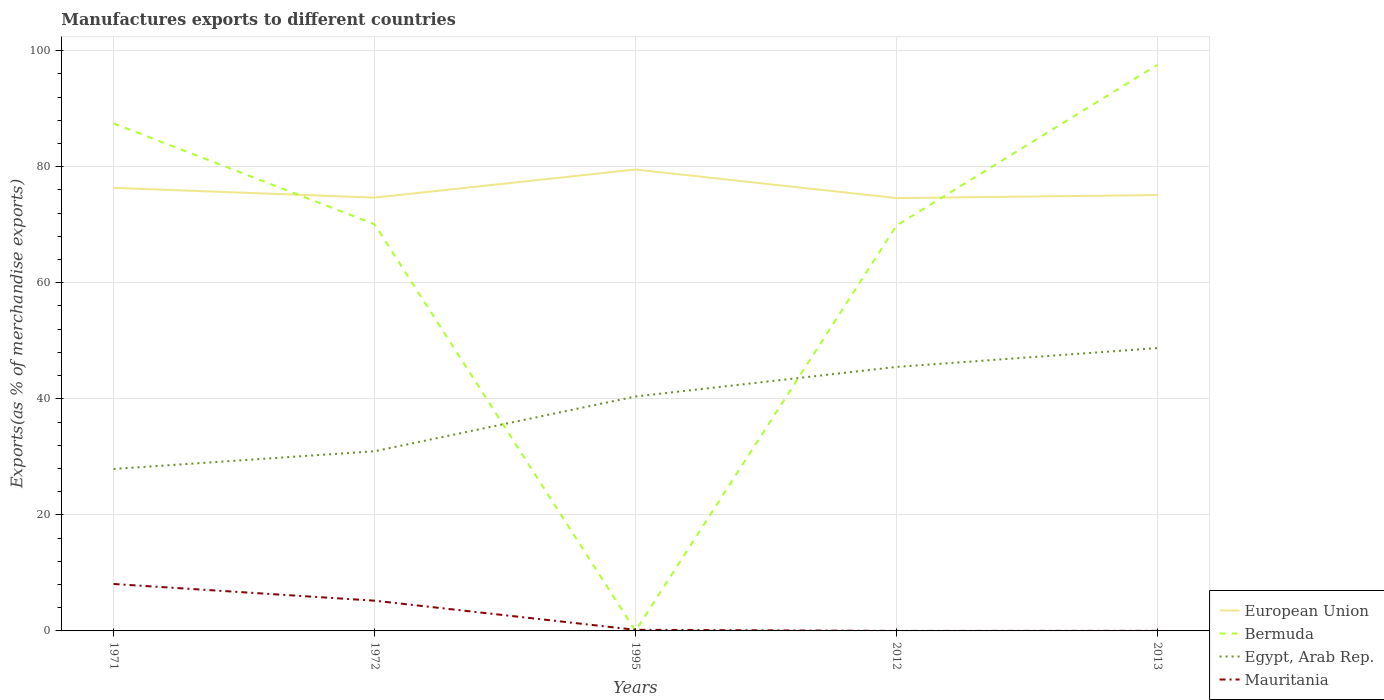How many different coloured lines are there?
Give a very brief answer. 4. Does the line corresponding to Egypt, Arab Rep. intersect with the line corresponding to Bermuda?
Offer a terse response. Yes. Is the number of lines equal to the number of legend labels?
Provide a succinct answer. Yes. Across all years, what is the maximum percentage of exports to different countries in European Union?
Provide a succinct answer. 74.58. In which year was the percentage of exports to different countries in Egypt, Arab Rep. maximum?
Keep it short and to the point. 1971. What is the total percentage of exports to different countries in Egypt, Arab Rep. in the graph?
Provide a short and direct response. -17.58. What is the difference between the highest and the second highest percentage of exports to different countries in Egypt, Arab Rep.?
Your answer should be very brief. 20.83. How many years are there in the graph?
Your response must be concise. 5. What is the difference between two consecutive major ticks on the Y-axis?
Provide a succinct answer. 20. How many legend labels are there?
Your response must be concise. 4. What is the title of the graph?
Give a very brief answer. Manufactures exports to different countries. Does "New Caledonia" appear as one of the legend labels in the graph?
Provide a succinct answer. No. What is the label or title of the X-axis?
Offer a very short reply. Years. What is the label or title of the Y-axis?
Offer a terse response. Exports(as % of merchandise exports). What is the Exports(as % of merchandise exports) of European Union in 1971?
Keep it short and to the point. 76.35. What is the Exports(as % of merchandise exports) of Bermuda in 1971?
Your response must be concise. 87.46. What is the Exports(as % of merchandise exports) in Egypt, Arab Rep. in 1971?
Keep it short and to the point. 27.91. What is the Exports(as % of merchandise exports) in Mauritania in 1971?
Give a very brief answer. 8.09. What is the Exports(as % of merchandise exports) in European Union in 1972?
Your answer should be very brief. 74.67. What is the Exports(as % of merchandise exports) of Bermuda in 1972?
Provide a short and direct response. 70.08. What is the Exports(as % of merchandise exports) in Egypt, Arab Rep. in 1972?
Offer a very short reply. 30.96. What is the Exports(as % of merchandise exports) in Mauritania in 1972?
Offer a very short reply. 5.21. What is the Exports(as % of merchandise exports) in European Union in 1995?
Make the answer very short. 79.51. What is the Exports(as % of merchandise exports) of Bermuda in 1995?
Your answer should be compact. 0.01. What is the Exports(as % of merchandise exports) of Egypt, Arab Rep. in 1995?
Keep it short and to the point. 40.4. What is the Exports(as % of merchandise exports) in Mauritania in 1995?
Provide a short and direct response. 0.19. What is the Exports(as % of merchandise exports) in European Union in 2012?
Give a very brief answer. 74.58. What is the Exports(as % of merchandise exports) in Bermuda in 2012?
Ensure brevity in your answer.  69.85. What is the Exports(as % of merchandise exports) in Egypt, Arab Rep. in 2012?
Your answer should be compact. 45.49. What is the Exports(as % of merchandise exports) of Mauritania in 2012?
Your answer should be compact. 0. What is the Exports(as % of merchandise exports) in European Union in 2013?
Provide a short and direct response. 75.11. What is the Exports(as % of merchandise exports) of Bermuda in 2013?
Your answer should be compact. 97.54. What is the Exports(as % of merchandise exports) of Egypt, Arab Rep. in 2013?
Your answer should be compact. 48.74. What is the Exports(as % of merchandise exports) in Mauritania in 2013?
Your answer should be compact. 0.02. Across all years, what is the maximum Exports(as % of merchandise exports) in European Union?
Offer a terse response. 79.51. Across all years, what is the maximum Exports(as % of merchandise exports) in Bermuda?
Offer a terse response. 97.54. Across all years, what is the maximum Exports(as % of merchandise exports) of Egypt, Arab Rep.?
Give a very brief answer. 48.74. Across all years, what is the maximum Exports(as % of merchandise exports) in Mauritania?
Make the answer very short. 8.09. Across all years, what is the minimum Exports(as % of merchandise exports) in European Union?
Make the answer very short. 74.58. Across all years, what is the minimum Exports(as % of merchandise exports) in Bermuda?
Keep it short and to the point. 0.01. Across all years, what is the minimum Exports(as % of merchandise exports) in Egypt, Arab Rep.?
Give a very brief answer. 27.91. Across all years, what is the minimum Exports(as % of merchandise exports) in Mauritania?
Your response must be concise. 0. What is the total Exports(as % of merchandise exports) of European Union in the graph?
Ensure brevity in your answer.  380.22. What is the total Exports(as % of merchandise exports) of Bermuda in the graph?
Keep it short and to the point. 324.94. What is the total Exports(as % of merchandise exports) of Egypt, Arab Rep. in the graph?
Offer a very short reply. 193.5. What is the total Exports(as % of merchandise exports) in Mauritania in the graph?
Provide a succinct answer. 13.51. What is the difference between the Exports(as % of merchandise exports) in European Union in 1971 and that in 1972?
Keep it short and to the point. 1.68. What is the difference between the Exports(as % of merchandise exports) in Bermuda in 1971 and that in 1972?
Provide a succinct answer. 17.37. What is the difference between the Exports(as % of merchandise exports) in Egypt, Arab Rep. in 1971 and that in 1972?
Provide a succinct answer. -3.05. What is the difference between the Exports(as % of merchandise exports) of Mauritania in 1971 and that in 1972?
Your answer should be very brief. 2.88. What is the difference between the Exports(as % of merchandise exports) of European Union in 1971 and that in 1995?
Ensure brevity in your answer.  -3.16. What is the difference between the Exports(as % of merchandise exports) in Bermuda in 1971 and that in 1995?
Your answer should be very brief. 87.45. What is the difference between the Exports(as % of merchandise exports) of Egypt, Arab Rep. in 1971 and that in 1995?
Ensure brevity in your answer.  -12.49. What is the difference between the Exports(as % of merchandise exports) in Mauritania in 1971 and that in 1995?
Make the answer very short. 7.9. What is the difference between the Exports(as % of merchandise exports) in European Union in 1971 and that in 2012?
Offer a very short reply. 1.76. What is the difference between the Exports(as % of merchandise exports) of Bermuda in 1971 and that in 2012?
Offer a terse response. 17.61. What is the difference between the Exports(as % of merchandise exports) in Egypt, Arab Rep. in 1971 and that in 2012?
Your answer should be very brief. -17.58. What is the difference between the Exports(as % of merchandise exports) in Mauritania in 1971 and that in 2012?
Offer a very short reply. 8.09. What is the difference between the Exports(as % of merchandise exports) in European Union in 1971 and that in 2013?
Your answer should be very brief. 1.24. What is the difference between the Exports(as % of merchandise exports) of Bermuda in 1971 and that in 2013?
Ensure brevity in your answer.  -10.08. What is the difference between the Exports(as % of merchandise exports) of Egypt, Arab Rep. in 1971 and that in 2013?
Provide a succinct answer. -20.83. What is the difference between the Exports(as % of merchandise exports) of Mauritania in 1971 and that in 2013?
Ensure brevity in your answer.  8.07. What is the difference between the Exports(as % of merchandise exports) in European Union in 1972 and that in 1995?
Make the answer very short. -4.84. What is the difference between the Exports(as % of merchandise exports) of Bermuda in 1972 and that in 1995?
Keep it short and to the point. 70.07. What is the difference between the Exports(as % of merchandise exports) of Egypt, Arab Rep. in 1972 and that in 1995?
Provide a short and direct response. -9.44. What is the difference between the Exports(as % of merchandise exports) of Mauritania in 1972 and that in 1995?
Your answer should be compact. 5.02. What is the difference between the Exports(as % of merchandise exports) of European Union in 1972 and that in 2012?
Provide a succinct answer. 0.08. What is the difference between the Exports(as % of merchandise exports) in Bermuda in 1972 and that in 2012?
Your answer should be compact. 0.24. What is the difference between the Exports(as % of merchandise exports) of Egypt, Arab Rep. in 1972 and that in 2012?
Provide a succinct answer. -14.53. What is the difference between the Exports(as % of merchandise exports) in Mauritania in 1972 and that in 2012?
Keep it short and to the point. 5.21. What is the difference between the Exports(as % of merchandise exports) in European Union in 1972 and that in 2013?
Make the answer very short. -0.45. What is the difference between the Exports(as % of merchandise exports) of Bermuda in 1972 and that in 2013?
Your answer should be compact. -27.46. What is the difference between the Exports(as % of merchandise exports) of Egypt, Arab Rep. in 1972 and that in 2013?
Make the answer very short. -17.78. What is the difference between the Exports(as % of merchandise exports) in Mauritania in 1972 and that in 2013?
Keep it short and to the point. 5.2. What is the difference between the Exports(as % of merchandise exports) in European Union in 1995 and that in 2012?
Your response must be concise. 4.93. What is the difference between the Exports(as % of merchandise exports) in Bermuda in 1995 and that in 2012?
Offer a terse response. -69.84. What is the difference between the Exports(as % of merchandise exports) of Egypt, Arab Rep. in 1995 and that in 2012?
Your answer should be compact. -5.09. What is the difference between the Exports(as % of merchandise exports) of Mauritania in 1995 and that in 2012?
Your answer should be compact. 0.19. What is the difference between the Exports(as % of merchandise exports) of European Union in 1995 and that in 2013?
Provide a short and direct response. 4.4. What is the difference between the Exports(as % of merchandise exports) of Bermuda in 1995 and that in 2013?
Offer a terse response. -97.53. What is the difference between the Exports(as % of merchandise exports) in Egypt, Arab Rep. in 1995 and that in 2013?
Give a very brief answer. -8.34. What is the difference between the Exports(as % of merchandise exports) of Mauritania in 1995 and that in 2013?
Make the answer very short. 0.18. What is the difference between the Exports(as % of merchandise exports) of European Union in 2012 and that in 2013?
Provide a short and direct response. -0.53. What is the difference between the Exports(as % of merchandise exports) of Bermuda in 2012 and that in 2013?
Provide a succinct answer. -27.7. What is the difference between the Exports(as % of merchandise exports) in Egypt, Arab Rep. in 2012 and that in 2013?
Keep it short and to the point. -3.25. What is the difference between the Exports(as % of merchandise exports) of Mauritania in 2012 and that in 2013?
Provide a short and direct response. -0.01. What is the difference between the Exports(as % of merchandise exports) in European Union in 1971 and the Exports(as % of merchandise exports) in Bermuda in 1972?
Offer a very short reply. 6.26. What is the difference between the Exports(as % of merchandise exports) of European Union in 1971 and the Exports(as % of merchandise exports) of Egypt, Arab Rep. in 1972?
Provide a short and direct response. 45.39. What is the difference between the Exports(as % of merchandise exports) in European Union in 1971 and the Exports(as % of merchandise exports) in Mauritania in 1972?
Provide a succinct answer. 71.14. What is the difference between the Exports(as % of merchandise exports) in Bermuda in 1971 and the Exports(as % of merchandise exports) in Egypt, Arab Rep. in 1972?
Provide a short and direct response. 56.5. What is the difference between the Exports(as % of merchandise exports) in Bermuda in 1971 and the Exports(as % of merchandise exports) in Mauritania in 1972?
Ensure brevity in your answer.  82.25. What is the difference between the Exports(as % of merchandise exports) in Egypt, Arab Rep. in 1971 and the Exports(as % of merchandise exports) in Mauritania in 1972?
Offer a very short reply. 22.7. What is the difference between the Exports(as % of merchandise exports) of European Union in 1971 and the Exports(as % of merchandise exports) of Bermuda in 1995?
Keep it short and to the point. 76.34. What is the difference between the Exports(as % of merchandise exports) of European Union in 1971 and the Exports(as % of merchandise exports) of Egypt, Arab Rep. in 1995?
Ensure brevity in your answer.  35.95. What is the difference between the Exports(as % of merchandise exports) of European Union in 1971 and the Exports(as % of merchandise exports) of Mauritania in 1995?
Ensure brevity in your answer.  76.16. What is the difference between the Exports(as % of merchandise exports) in Bermuda in 1971 and the Exports(as % of merchandise exports) in Egypt, Arab Rep. in 1995?
Offer a very short reply. 47.06. What is the difference between the Exports(as % of merchandise exports) in Bermuda in 1971 and the Exports(as % of merchandise exports) in Mauritania in 1995?
Your answer should be very brief. 87.26. What is the difference between the Exports(as % of merchandise exports) of Egypt, Arab Rep. in 1971 and the Exports(as % of merchandise exports) of Mauritania in 1995?
Your answer should be compact. 27.71. What is the difference between the Exports(as % of merchandise exports) of European Union in 1971 and the Exports(as % of merchandise exports) of Bermuda in 2012?
Your answer should be compact. 6.5. What is the difference between the Exports(as % of merchandise exports) of European Union in 1971 and the Exports(as % of merchandise exports) of Egypt, Arab Rep. in 2012?
Keep it short and to the point. 30.86. What is the difference between the Exports(as % of merchandise exports) in European Union in 1971 and the Exports(as % of merchandise exports) in Mauritania in 2012?
Offer a terse response. 76.35. What is the difference between the Exports(as % of merchandise exports) in Bermuda in 1971 and the Exports(as % of merchandise exports) in Egypt, Arab Rep. in 2012?
Make the answer very short. 41.97. What is the difference between the Exports(as % of merchandise exports) of Bermuda in 1971 and the Exports(as % of merchandise exports) of Mauritania in 2012?
Ensure brevity in your answer.  87.46. What is the difference between the Exports(as % of merchandise exports) of Egypt, Arab Rep. in 1971 and the Exports(as % of merchandise exports) of Mauritania in 2012?
Keep it short and to the point. 27.91. What is the difference between the Exports(as % of merchandise exports) in European Union in 1971 and the Exports(as % of merchandise exports) in Bermuda in 2013?
Give a very brief answer. -21.19. What is the difference between the Exports(as % of merchandise exports) of European Union in 1971 and the Exports(as % of merchandise exports) of Egypt, Arab Rep. in 2013?
Give a very brief answer. 27.61. What is the difference between the Exports(as % of merchandise exports) of European Union in 1971 and the Exports(as % of merchandise exports) of Mauritania in 2013?
Offer a very short reply. 76.33. What is the difference between the Exports(as % of merchandise exports) in Bermuda in 1971 and the Exports(as % of merchandise exports) in Egypt, Arab Rep. in 2013?
Make the answer very short. 38.72. What is the difference between the Exports(as % of merchandise exports) in Bermuda in 1971 and the Exports(as % of merchandise exports) in Mauritania in 2013?
Your answer should be compact. 87.44. What is the difference between the Exports(as % of merchandise exports) in Egypt, Arab Rep. in 1971 and the Exports(as % of merchandise exports) in Mauritania in 2013?
Give a very brief answer. 27.89. What is the difference between the Exports(as % of merchandise exports) in European Union in 1972 and the Exports(as % of merchandise exports) in Bermuda in 1995?
Provide a short and direct response. 74.66. What is the difference between the Exports(as % of merchandise exports) of European Union in 1972 and the Exports(as % of merchandise exports) of Egypt, Arab Rep. in 1995?
Provide a succinct answer. 34.27. What is the difference between the Exports(as % of merchandise exports) of European Union in 1972 and the Exports(as % of merchandise exports) of Mauritania in 1995?
Your response must be concise. 74.47. What is the difference between the Exports(as % of merchandise exports) of Bermuda in 1972 and the Exports(as % of merchandise exports) of Egypt, Arab Rep. in 1995?
Make the answer very short. 29.69. What is the difference between the Exports(as % of merchandise exports) in Bermuda in 1972 and the Exports(as % of merchandise exports) in Mauritania in 1995?
Keep it short and to the point. 69.89. What is the difference between the Exports(as % of merchandise exports) of Egypt, Arab Rep. in 1972 and the Exports(as % of merchandise exports) of Mauritania in 1995?
Ensure brevity in your answer.  30.77. What is the difference between the Exports(as % of merchandise exports) of European Union in 1972 and the Exports(as % of merchandise exports) of Bermuda in 2012?
Make the answer very short. 4.82. What is the difference between the Exports(as % of merchandise exports) in European Union in 1972 and the Exports(as % of merchandise exports) in Egypt, Arab Rep. in 2012?
Offer a very short reply. 29.18. What is the difference between the Exports(as % of merchandise exports) of European Union in 1972 and the Exports(as % of merchandise exports) of Mauritania in 2012?
Provide a succinct answer. 74.67. What is the difference between the Exports(as % of merchandise exports) of Bermuda in 1972 and the Exports(as % of merchandise exports) of Egypt, Arab Rep. in 2012?
Your answer should be compact. 24.59. What is the difference between the Exports(as % of merchandise exports) of Bermuda in 1972 and the Exports(as % of merchandise exports) of Mauritania in 2012?
Offer a very short reply. 70.08. What is the difference between the Exports(as % of merchandise exports) of Egypt, Arab Rep. in 1972 and the Exports(as % of merchandise exports) of Mauritania in 2012?
Your response must be concise. 30.96. What is the difference between the Exports(as % of merchandise exports) in European Union in 1972 and the Exports(as % of merchandise exports) in Bermuda in 2013?
Provide a short and direct response. -22.88. What is the difference between the Exports(as % of merchandise exports) in European Union in 1972 and the Exports(as % of merchandise exports) in Egypt, Arab Rep. in 2013?
Provide a succinct answer. 25.93. What is the difference between the Exports(as % of merchandise exports) of European Union in 1972 and the Exports(as % of merchandise exports) of Mauritania in 2013?
Provide a short and direct response. 74.65. What is the difference between the Exports(as % of merchandise exports) of Bermuda in 1972 and the Exports(as % of merchandise exports) of Egypt, Arab Rep. in 2013?
Ensure brevity in your answer.  21.34. What is the difference between the Exports(as % of merchandise exports) in Bermuda in 1972 and the Exports(as % of merchandise exports) in Mauritania in 2013?
Your answer should be compact. 70.07. What is the difference between the Exports(as % of merchandise exports) of Egypt, Arab Rep. in 1972 and the Exports(as % of merchandise exports) of Mauritania in 2013?
Provide a succinct answer. 30.94. What is the difference between the Exports(as % of merchandise exports) in European Union in 1995 and the Exports(as % of merchandise exports) in Bermuda in 2012?
Offer a very short reply. 9.66. What is the difference between the Exports(as % of merchandise exports) in European Union in 1995 and the Exports(as % of merchandise exports) in Egypt, Arab Rep. in 2012?
Ensure brevity in your answer.  34.02. What is the difference between the Exports(as % of merchandise exports) in European Union in 1995 and the Exports(as % of merchandise exports) in Mauritania in 2012?
Give a very brief answer. 79.51. What is the difference between the Exports(as % of merchandise exports) of Bermuda in 1995 and the Exports(as % of merchandise exports) of Egypt, Arab Rep. in 2012?
Your answer should be compact. -45.48. What is the difference between the Exports(as % of merchandise exports) in Bermuda in 1995 and the Exports(as % of merchandise exports) in Mauritania in 2012?
Your answer should be very brief. 0.01. What is the difference between the Exports(as % of merchandise exports) in Egypt, Arab Rep. in 1995 and the Exports(as % of merchandise exports) in Mauritania in 2012?
Your response must be concise. 40.4. What is the difference between the Exports(as % of merchandise exports) in European Union in 1995 and the Exports(as % of merchandise exports) in Bermuda in 2013?
Give a very brief answer. -18.03. What is the difference between the Exports(as % of merchandise exports) in European Union in 1995 and the Exports(as % of merchandise exports) in Egypt, Arab Rep. in 2013?
Make the answer very short. 30.77. What is the difference between the Exports(as % of merchandise exports) of European Union in 1995 and the Exports(as % of merchandise exports) of Mauritania in 2013?
Offer a very short reply. 79.49. What is the difference between the Exports(as % of merchandise exports) in Bermuda in 1995 and the Exports(as % of merchandise exports) in Egypt, Arab Rep. in 2013?
Provide a short and direct response. -48.73. What is the difference between the Exports(as % of merchandise exports) of Bermuda in 1995 and the Exports(as % of merchandise exports) of Mauritania in 2013?
Provide a short and direct response. -0.01. What is the difference between the Exports(as % of merchandise exports) in Egypt, Arab Rep. in 1995 and the Exports(as % of merchandise exports) in Mauritania in 2013?
Your answer should be very brief. 40.38. What is the difference between the Exports(as % of merchandise exports) in European Union in 2012 and the Exports(as % of merchandise exports) in Bermuda in 2013?
Your response must be concise. -22.96. What is the difference between the Exports(as % of merchandise exports) of European Union in 2012 and the Exports(as % of merchandise exports) of Egypt, Arab Rep. in 2013?
Offer a terse response. 25.84. What is the difference between the Exports(as % of merchandise exports) in European Union in 2012 and the Exports(as % of merchandise exports) in Mauritania in 2013?
Your response must be concise. 74.57. What is the difference between the Exports(as % of merchandise exports) in Bermuda in 2012 and the Exports(as % of merchandise exports) in Egypt, Arab Rep. in 2013?
Give a very brief answer. 21.1. What is the difference between the Exports(as % of merchandise exports) in Bermuda in 2012 and the Exports(as % of merchandise exports) in Mauritania in 2013?
Make the answer very short. 69.83. What is the difference between the Exports(as % of merchandise exports) in Egypt, Arab Rep. in 2012 and the Exports(as % of merchandise exports) in Mauritania in 2013?
Make the answer very short. 45.48. What is the average Exports(as % of merchandise exports) of European Union per year?
Offer a terse response. 76.04. What is the average Exports(as % of merchandise exports) of Bermuda per year?
Keep it short and to the point. 64.99. What is the average Exports(as % of merchandise exports) of Egypt, Arab Rep. per year?
Offer a very short reply. 38.7. What is the average Exports(as % of merchandise exports) in Mauritania per year?
Provide a succinct answer. 2.7. In the year 1971, what is the difference between the Exports(as % of merchandise exports) of European Union and Exports(as % of merchandise exports) of Bermuda?
Provide a short and direct response. -11.11. In the year 1971, what is the difference between the Exports(as % of merchandise exports) in European Union and Exports(as % of merchandise exports) in Egypt, Arab Rep.?
Keep it short and to the point. 48.44. In the year 1971, what is the difference between the Exports(as % of merchandise exports) in European Union and Exports(as % of merchandise exports) in Mauritania?
Give a very brief answer. 68.26. In the year 1971, what is the difference between the Exports(as % of merchandise exports) of Bermuda and Exports(as % of merchandise exports) of Egypt, Arab Rep.?
Make the answer very short. 59.55. In the year 1971, what is the difference between the Exports(as % of merchandise exports) in Bermuda and Exports(as % of merchandise exports) in Mauritania?
Offer a terse response. 79.37. In the year 1971, what is the difference between the Exports(as % of merchandise exports) of Egypt, Arab Rep. and Exports(as % of merchandise exports) of Mauritania?
Provide a short and direct response. 19.82. In the year 1972, what is the difference between the Exports(as % of merchandise exports) of European Union and Exports(as % of merchandise exports) of Bermuda?
Provide a succinct answer. 4.58. In the year 1972, what is the difference between the Exports(as % of merchandise exports) in European Union and Exports(as % of merchandise exports) in Egypt, Arab Rep.?
Your answer should be very brief. 43.71. In the year 1972, what is the difference between the Exports(as % of merchandise exports) in European Union and Exports(as % of merchandise exports) in Mauritania?
Your answer should be compact. 69.46. In the year 1972, what is the difference between the Exports(as % of merchandise exports) in Bermuda and Exports(as % of merchandise exports) in Egypt, Arab Rep.?
Keep it short and to the point. 39.12. In the year 1972, what is the difference between the Exports(as % of merchandise exports) of Bermuda and Exports(as % of merchandise exports) of Mauritania?
Give a very brief answer. 64.87. In the year 1972, what is the difference between the Exports(as % of merchandise exports) in Egypt, Arab Rep. and Exports(as % of merchandise exports) in Mauritania?
Your answer should be very brief. 25.75. In the year 1995, what is the difference between the Exports(as % of merchandise exports) in European Union and Exports(as % of merchandise exports) in Bermuda?
Your answer should be compact. 79.5. In the year 1995, what is the difference between the Exports(as % of merchandise exports) of European Union and Exports(as % of merchandise exports) of Egypt, Arab Rep.?
Provide a short and direct response. 39.11. In the year 1995, what is the difference between the Exports(as % of merchandise exports) of European Union and Exports(as % of merchandise exports) of Mauritania?
Offer a very short reply. 79.32. In the year 1995, what is the difference between the Exports(as % of merchandise exports) in Bermuda and Exports(as % of merchandise exports) in Egypt, Arab Rep.?
Offer a terse response. -40.39. In the year 1995, what is the difference between the Exports(as % of merchandise exports) in Bermuda and Exports(as % of merchandise exports) in Mauritania?
Provide a succinct answer. -0.18. In the year 1995, what is the difference between the Exports(as % of merchandise exports) of Egypt, Arab Rep. and Exports(as % of merchandise exports) of Mauritania?
Provide a succinct answer. 40.2. In the year 2012, what is the difference between the Exports(as % of merchandise exports) in European Union and Exports(as % of merchandise exports) in Bermuda?
Offer a terse response. 4.74. In the year 2012, what is the difference between the Exports(as % of merchandise exports) of European Union and Exports(as % of merchandise exports) of Egypt, Arab Rep.?
Your answer should be very brief. 29.09. In the year 2012, what is the difference between the Exports(as % of merchandise exports) of European Union and Exports(as % of merchandise exports) of Mauritania?
Provide a succinct answer. 74.58. In the year 2012, what is the difference between the Exports(as % of merchandise exports) of Bermuda and Exports(as % of merchandise exports) of Egypt, Arab Rep.?
Provide a succinct answer. 24.35. In the year 2012, what is the difference between the Exports(as % of merchandise exports) of Bermuda and Exports(as % of merchandise exports) of Mauritania?
Offer a very short reply. 69.84. In the year 2012, what is the difference between the Exports(as % of merchandise exports) in Egypt, Arab Rep. and Exports(as % of merchandise exports) in Mauritania?
Your answer should be compact. 45.49. In the year 2013, what is the difference between the Exports(as % of merchandise exports) of European Union and Exports(as % of merchandise exports) of Bermuda?
Your answer should be compact. -22.43. In the year 2013, what is the difference between the Exports(as % of merchandise exports) in European Union and Exports(as % of merchandise exports) in Egypt, Arab Rep.?
Ensure brevity in your answer.  26.37. In the year 2013, what is the difference between the Exports(as % of merchandise exports) of European Union and Exports(as % of merchandise exports) of Mauritania?
Give a very brief answer. 75.1. In the year 2013, what is the difference between the Exports(as % of merchandise exports) in Bermuda and Exports(as % of merchandise exports) in Egypt, Arab Rep.?
Ensure brevity in your answer.  48.8. In the year 2013, what is the difference between the Exports(as % of merchandise exports) in Bermuda and Exports(as % of merchandise exports) in Mauritania?
Your answer should be very brief. 97.53. In the year 2013, what is the difference between the Exports(as % of merchandise exports) of Egypt, Arab Rep. and Exports(as % of merchandise exports) of Mauritania?
Your answer should be very brief. 48.73. What is the ratio of the Exports(as % of merchandise exports) in European Union in 1971 to that in 1972?
Your answer should be very brief. 1.02. What is the ratio of the Exports(as % of merchandise exports) of Bermuda in 1971 to that in 1972?
Provide a succinct answer. 1.25. What is the ratio of the Exports(as % of merchandise exports) in Egypt, Arab Rep. in 1971 to that in 1972?
Your answer should be very brief. 0.9. What is the ratio of the Exports(as % of merchandise exports) of Mauritania in 1971 to that in 1972?
Give a very brief answer. 1.55. What is the ratio of the Exports(as % of merchandise exports) of European Union in 1971 to that in 1995?
Give a very brief answer. 0.96. What is the ratio of the Exports(as % of merchandise exports) of Bermuda in 1971 to that in 1995?
Your answer should be compact. 9489.04. What is the ratio of the Exports(as % of merchandise exports) in Egypt, Arab Rep. in 1971 to that in 1995?
Give a very brief answer. 0.69. What is the ratio of the Exports(as % of merchandise exports) of Mauritania in 1971 to that in 1995?
Your answer should be very brief. 41.95. What is the ratio of the Exports(as % of merchandise exports) of European Union in 1971 to that in 2012?
Your answer should be compact. 1.02. What is the ratio of the Exports(as % of merchandise exports) in Bermuda in 1971 to that in 2012?
Your answer should be compact. 1.25. What is the ratio of the Exports(as % of merchandise exports) of Egypt, Arab Rep. in 1971 to that in 2012?
Your answer should be compact. 0.61. What is the ratio of the Exports(as % of merchandise exports) of Mauritania in 1971 to that in 2012?
Keep it short and to the point. 5157.33. What is the ratio of the Exports(as % of merchandise exports) of European Union in 1971 to that in 2013?
Your answer should be compact. 1.02. What is the ratio of the Exports(as % of merchandise exports) in Bermuda in 1971 to that in 2013?
Your answer should be very brief. 0.9. What is the ratio of the Exports(as % of merchandise exports) of Egypt, Arab Rep. in 1971 to that in 2013?
Offer a terse response. 0.57. What is the ratio of the Exports(as % of merchandise exports) of Mauritania in 1971 to that in 2013?
Your response must be concise. 528.68. What is the ratio of the Exports(as % of merchandise exports) of European Union in 1972 to that in 1995?
Your answer should be compact. 0.94. What is the ratio of the Exports(as % of merchandise exports) in Bermuda in 1972 to that in 1995?
Provide a short and direct response. 7603.97. What is the ratio of the Exports(as % of merchandise exports) of Egypt, Arab Rep. in 1972 to that in 1995?
Ensure brevity in your answer.  0.77. What is the ratio of the Exports(as % of merchandise exports) in Mauritania in 1972 to that in 1995?
Provide a succinct answer. 27.03. What is the ratio of the Exports(as % of merchandise exports) of Bermuda in 1972 to that in 2012?
Make the answer very short. 1. What is the ratio of the Exports(as % of merchandise exports) in Egypt, Arab Rep. in 1972 to that in 2012?
Your answer should be very brief. 0.68. What is the ratio of the Exports(as % of merchandise exports) in Mauritania in 1972 to that in 2012?
Give a very brief answer. 3322.26. What is the ratio of the Exports(as % of merchandise exports) of Bermuda in 1972 to that in 2013?
Your response must be concise. 0.72. What is the ratio of the Exports(as % of merchandise exports) in Egypt, Arab Rep. in 1972 to that in 2013?
Provide a succinct answer. 0.64. What is the ratio of the Exports(as % of merchandise exports) of Mauritania in 1972 to that in 2013?
Give a very brief answer. 340.56. What is the ratio of the Exports(as % of merchandise exports) in European Union in 1995 to that in 2012?
Keep it short and to the point. 1.07. What is the ratio of the Exports(as % of merchandise exports) of Bermuda in 1995 to that in 2012?
Your answer should be very brief. 0. What is the ratio of the Exports(as % of merchandise exports) in Egypt, Arab Rep. in 1995 to that in 2012?
Ensure brevity in your answer.  0.89. What is the ratio of the Exports(as % of merchandise exports) in Mauritania in 1995 to that in 2012?
Make the answer very short. 122.93. What is the ratio of the Exports(as % of merchandise exports) of European Union in 1995 to that in 2013?
Provide a short and direct response. 1.06. What is the ratio of the Exports(as % of merchandise exports) in Egypt, Arab Rep. in 1995 to that in 2013?
Offer a very short reply. 0.83. What is the ratio of the Exports(as % of merchandise exports) in Mauritania in 1995 to that in 2013?
Your answer should be very brief. 12.6. What is the ratio of the Exports(as % of merchandise exports) of European Union in 2012 to that in 2013?
Ensure brevity in your answer.  0.99. What is the ratio of the Exports(as % of merchandise exports) of Bermuda in 2012 to that in 2013?
Provide a short and direct response. 0.72. What is the ratio of the Exports(as % of merchandise exports) of Egypt, Arab Rep. in 2012 to that in 2013?
Ensure brevity in your answer.  0.93. What is the ratio of the Exports(as % of merchandise exports) in Mauritania in 2012 to that in 2013?
Your answer should be very brief. 0.1. What is the difference between the highest and the second highest Exports(as % of merchandise exports) in European Union?
Keep it short and to the point. 3.16. What is the difference between the highest and the second highest Exports(as % of merchandise exports) in Bermuda?
Your response must be concise. 10.08. What is the difference between the highest and the second highest Exports(as % of merchandise exports) of Egypt, Arab Rep.?
Provide a short and direct response. 3.25. What is the difference between the highest and the second highest Exports(as % of merchandise exports) in Mauritania?
Offer a terse response. 2.88. What is the difference between the highest and the lowest Exports(as % of merchandise exports) of European Union?
Make the answer very short. 4.93. What is the difference between the highest and the lowest Exports(as % of merchandise exports) in Bermuda?
Offer a very short reply. 97.53. What is the difference between the highest and the lowest Exports(as % of merchandise exports) in Egypt, Arab Rep.?
Make the answer very short. 20.83. What is the difference between the highest and the lowest Exports(as % of merchandise exports) of Mauritania?
Your response must be concise. 8.09. 